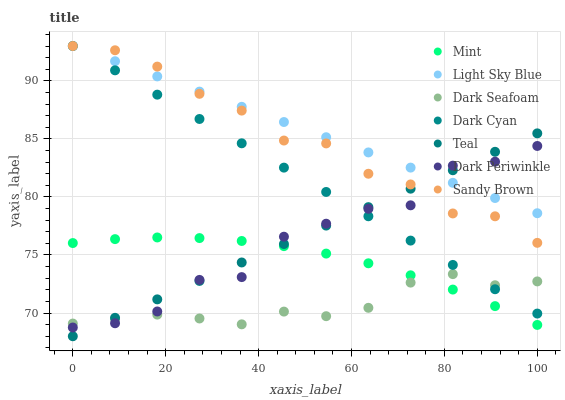Does Dark Seafoam have the minimum area under the curve?
Answer yes or no. Yes. Does Light Sky Blue have the maximum area under the curve?
Answer yes or no. Yes. Does Light Sky Blue have the minimum area under the curve?
Answer yes or no. No. Does Dark Seafoam have the maximum area under the curve?
Answer yes or no. No. Is Teal the smoothest?
Answer yes or no. Yes. Is Dark Periwinkle the roughest?
Answer yes or no. Yes. Is Dark Seafoam the smoothest?
Answer yes or no. No. Is Dark Seafoam the roughest?
Answer yes or no. No. Does Teal have the lowest value?
Answer yes or no. Yes. Does Dark Seafoam have the lowest value?
Answer yes or no. No. Does Dark Cyan have the highest value?
Answer yes or no. Yes. Does Dark Seafoam have the highest value?
Answer yes or no. No. Is Mint less than Dark Cyan?
Answer yes or no. Yes. Is Dark Cyan greater than Mint?
Answer yes or no. Yes. Does Mint intersect Teal?
Answer yes or no. Yes. Is Mint less than Teal?
Answer yes or no. No. Is Mint greater than Teal?
Answer yes or no. No. Does Mint intersect Dark Cyan?
Answer yes or no. No. 